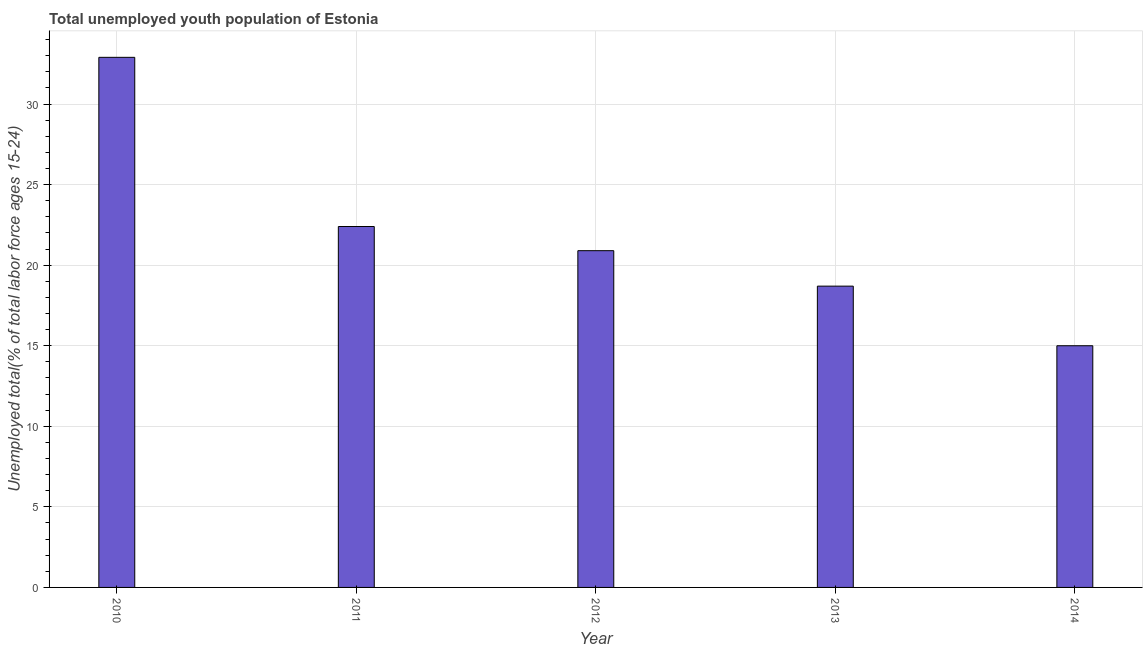Does the graph contain any zero values?
Your answer should be very brief. No. Does the graph contain grids?
Your answer should be very brief. Yes. What is the title of the graph?
Make the answer very short. Total unemployed youth population of Estonia. What is the label or title of the Y-axis?
Provide a succinct answer. Unemployed total(% of total labor force ages 15-24). Across all years, what is the maximum unemployed youth?
Offer a very short reply. 32.9. Across all years, what is the minimum unemployed youth?
Your answer should be very brief. 15. What is the sum of the unemployed youth?
Give a very brief answer. 109.9. What is the difference between the unemployed youth in 2010 and 2013?
Provide a short and direct response. 14.2. What is the average unemployed youth per year?
Give a very brief answer. 21.98. What is the median unemployed youth?
Ensure brevity in your answer.  20.9. In how many years, is the unemployed youth greater than 23 %?
Your answer should be very brief. 1. What is the ratio of the unemployed youth in 2012 to that in 2013?
Offer a terse response. 1.12. Is the unemployed youth in 2011 less than that in 2013?
Your answer should be compact. No. What is the difference between the highest and the second highest unemployed youth?
Provide a succinct answer. 10.5. Are all the bars in the graph horizontal?
Offer a very short reply. No. How many years are there in the graph?
Offer a very short reply. 5. Are the values on the major ticks of Y-axis written in scientific E-notation?
Your response must be concise. No. What is the Unemployed total(% of total labor force ages 15-24) of 2010?
Provide a short and direct response. 32.9. What is the Unemployed total(% of total labor force ages 15-24) of 2011?
Your response must be concise. 22.4. What is the Unemployed total(% of total labor force ages 15-24) in 2012?
Provide a succinct answer. 20.9. What is the Unemployed total(% of total labor force ages 15-24) of 2013?
Provide a succinct answer. 18.7. What is the difference between the Unemployed total(% of total labor force ages 15-24) in 2010 and 2012?
Provide a short and direct response. 12. What is the difference between the Unemployed total(% of total labor force ages 15-24) in 2010 and 2013?
Provide a short and direct response. 14.2. What is the difference between the Unemployed total(% of total labor force ages 15-24) in 2010 and 2014?
Keep it short and to the point. 17.9. What is the difference between the Unemployed total(% of total labor force ages 15-24) in 2011 and 2014?
Give a very brief answer. 7.4. What is the difference between the Unemployed total(% of total labor force ages 15-24) in 2012 and 2014?
Your response must be concise. 5.9. What is the ratio of the Unemployed total(% of total labor force ages 15-24) in 2010 to that in 2011?
Keep it short and to the point. 1.47. What is the ratio of the Unemployed total(% of total labor force ages 15-24) in 2010 to that in 2012?
Offer a very short reply. 1.57. What is the ratio of the Unemployed total(% of total labor force ages 15-24) in 2010 to that in 2013?
Give a very brief answer. 1.76. What is the ratio of the Unemployed total(% of total labor force ages 15-24) in 2010 to that in 2014?
Offer a terse response. 2.19. What is the ratio of the Unemployed total(% of total labor force ages 15-24) in 2011 to that in 2012?
Offer a very short reply. 1.07. What is the ratio of the Unemployed total(% of total labor force ages 15-24) in 2011 to that in 2013?
Offer a terse response. 1.2. What is the ratio of the Unemployed total(% of total labor force ages 15-24) in 2011 to that in 2014?
Your answer should be very brief. 1.49. What is the ratio of the Unemployed total(% of total labor force ages 15-24) in 2012 to that in 2013?
Offer a terse response. 1.12. What is the ratio of the Unemployed total(% of total labor force ages 15-24) in 2012 to that in 2014?
Your answer should be compact. 1.39. What is the ratio of the Unemployed total(% of total labor force ages 15-24) in 2013 to that in 2014?
Provide a succinct answer. 1.25. 